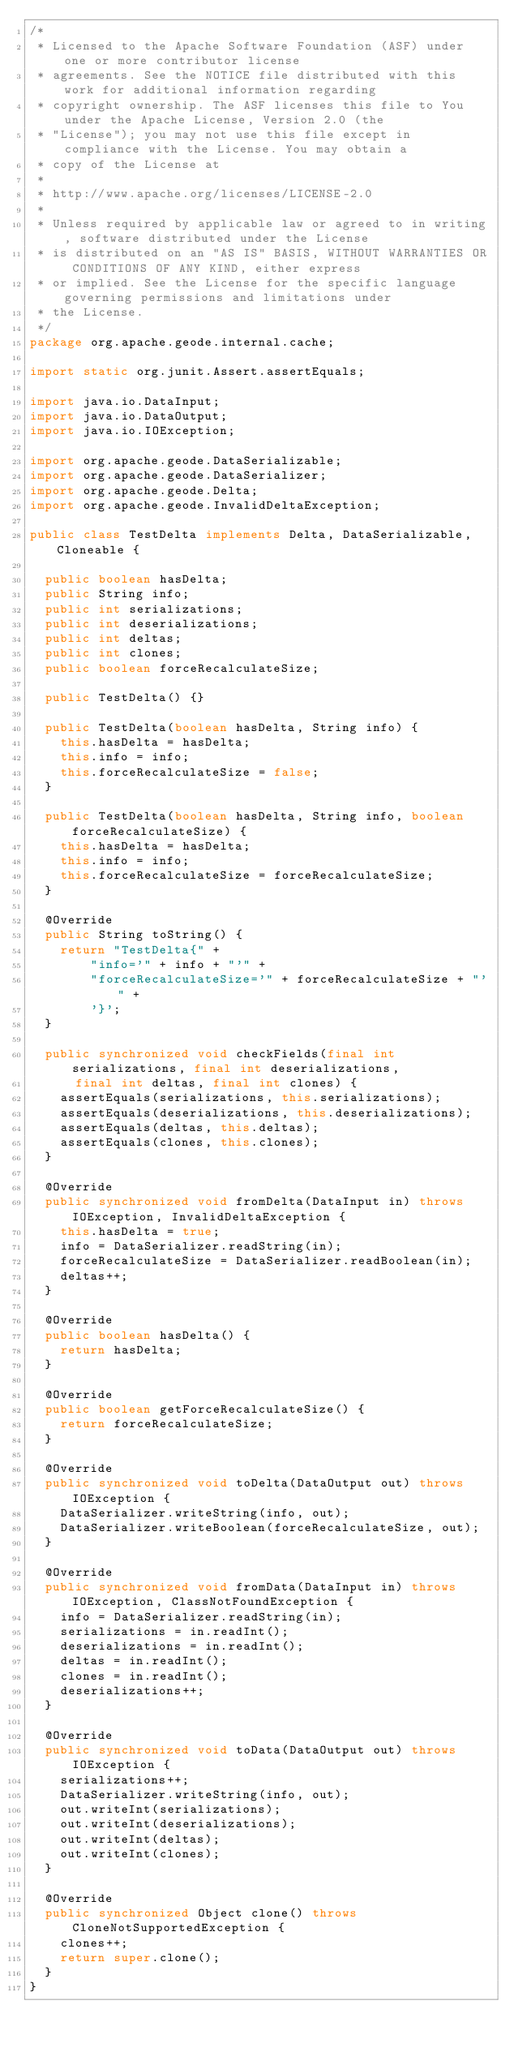Convert code to text. <code><loc_0><loc_0><loc_500><loc_500><_Java_>/*
 * Licensed to the Apache Software Foundation (ASF) under one or more contributor license
 * agreements. See the NOTICE file distributed with this work for additional information regarding
 * copyright ownership. The ASF licenses this file to You under the Apache License, Version 2.0 (the
 * "License"); you may not use this file except in compliance with the License. You may obtain a
 * copy of the License at
 *
 * http://www.apache.org/licenses/LICENSE-2.0
 *
 * Unless required by applicable law or agreed to in writing, software distributed under the License
 * is distributed on an "AS IS" BASIS, WITHOUT WARRANTIES OR CONDITIONS OF ANY KIND, either express
 * or implied. See the License for the specific language governing permissions and limitations under
 * the License.
 */
package org.apache.geode.internal.cache;

import static org.junit.Assert.assertEquals;

import java.io.DataInput;
import java.io.DataOutput;
import java.io.IOException;

import org.apache.geode.DataSerializable;
import org.apache.geode.DataSerializer;
import org.apache.geode.Delta;
import org.apache.geode.InvalidDeltaException;

public class TestDelta implements Delta, DataSerializable, Cloneable {

  public boolean hasDelta;
  public String info;
  public int serializations;
  public int deserializations;
  public int deltas;
  public int clones;
  public boolean forceRecalculateSize;

  public TestDelta() {}

  public TestDelta(boolean hasDelta, String info) {
    this.hasDelta = hasDelta;
    this.info = info;
    this.forceRecalculateSize = false;
  }

  public TestDelta(boolean hasDelta, String info, boolean forceRecalculateSize) {
    this.hasDelta = hasDelta;
    this.info = info;
    this.forceRecalculateSize = forceRecalculateSize;
  }

  @Override
  public String toString() {
    return "TestDelta{" +
        "info='" + info + "'" +
        "forceRecalculateSize='" + forceRecalculateSize + "'" +
        '}';
  }

  public synchronized void checkFields(final int serializations, final int deserializations,
      final int deltas, final int clones) {
    assertEquals(serializations, this.serializations);
    assertEquals(deserializations, this.deserializations);
    assertEquals(deltas, this.deltas);
    assertEquals(clones, this.clones);
  }

  @Override
  public synchronized void fromDelta(DataInput in) throws IOException, InvalidDeltaException {
    this.hasDelta = true;
    info = DataSerializer.readString(in);
    forceRecalculateSize = DataSerializer.readBoolean(in);
    deltas++;
  }

  @Override
  public boolean hasDelta() {
    return hasDelta;
  }

  @Override
  public boolean getForceRecalculateSize() {
    return forceRecalculateSize;
  }

  @Override
  public synchronized void toDelta(DataOutput out) throws IOException {
    DataSerializer.writeString(info, out);
    DataSerializer.writeBoolean(forceRecalculateSize, out);
  }

  @Override
  public synchronized void fromData(DataInput in) throws IOException, ClassNotFoundException {
    info = DataSerializer.readString(in);
    serializations = in.readInt();
    deserializations = in.readInt();
    deltas = in.readInt();
    clones = in.readInt();
    deserializations++;
  }

  @Override
  public synchronized void toData(DataOutput out) throws IOException {
    serializations++;
    DataSerializer.writeString(info, out);
    out.writeInt(serializations);
    out.writeInt(deserializations);
    out.writeInt(deltas);
    out.writeInt(clones);
  }

  @Override
  public synchronized Object clone() throws CloneNotSupportedException {
    clones++;
    return super.clone();
  }
}
</code> 